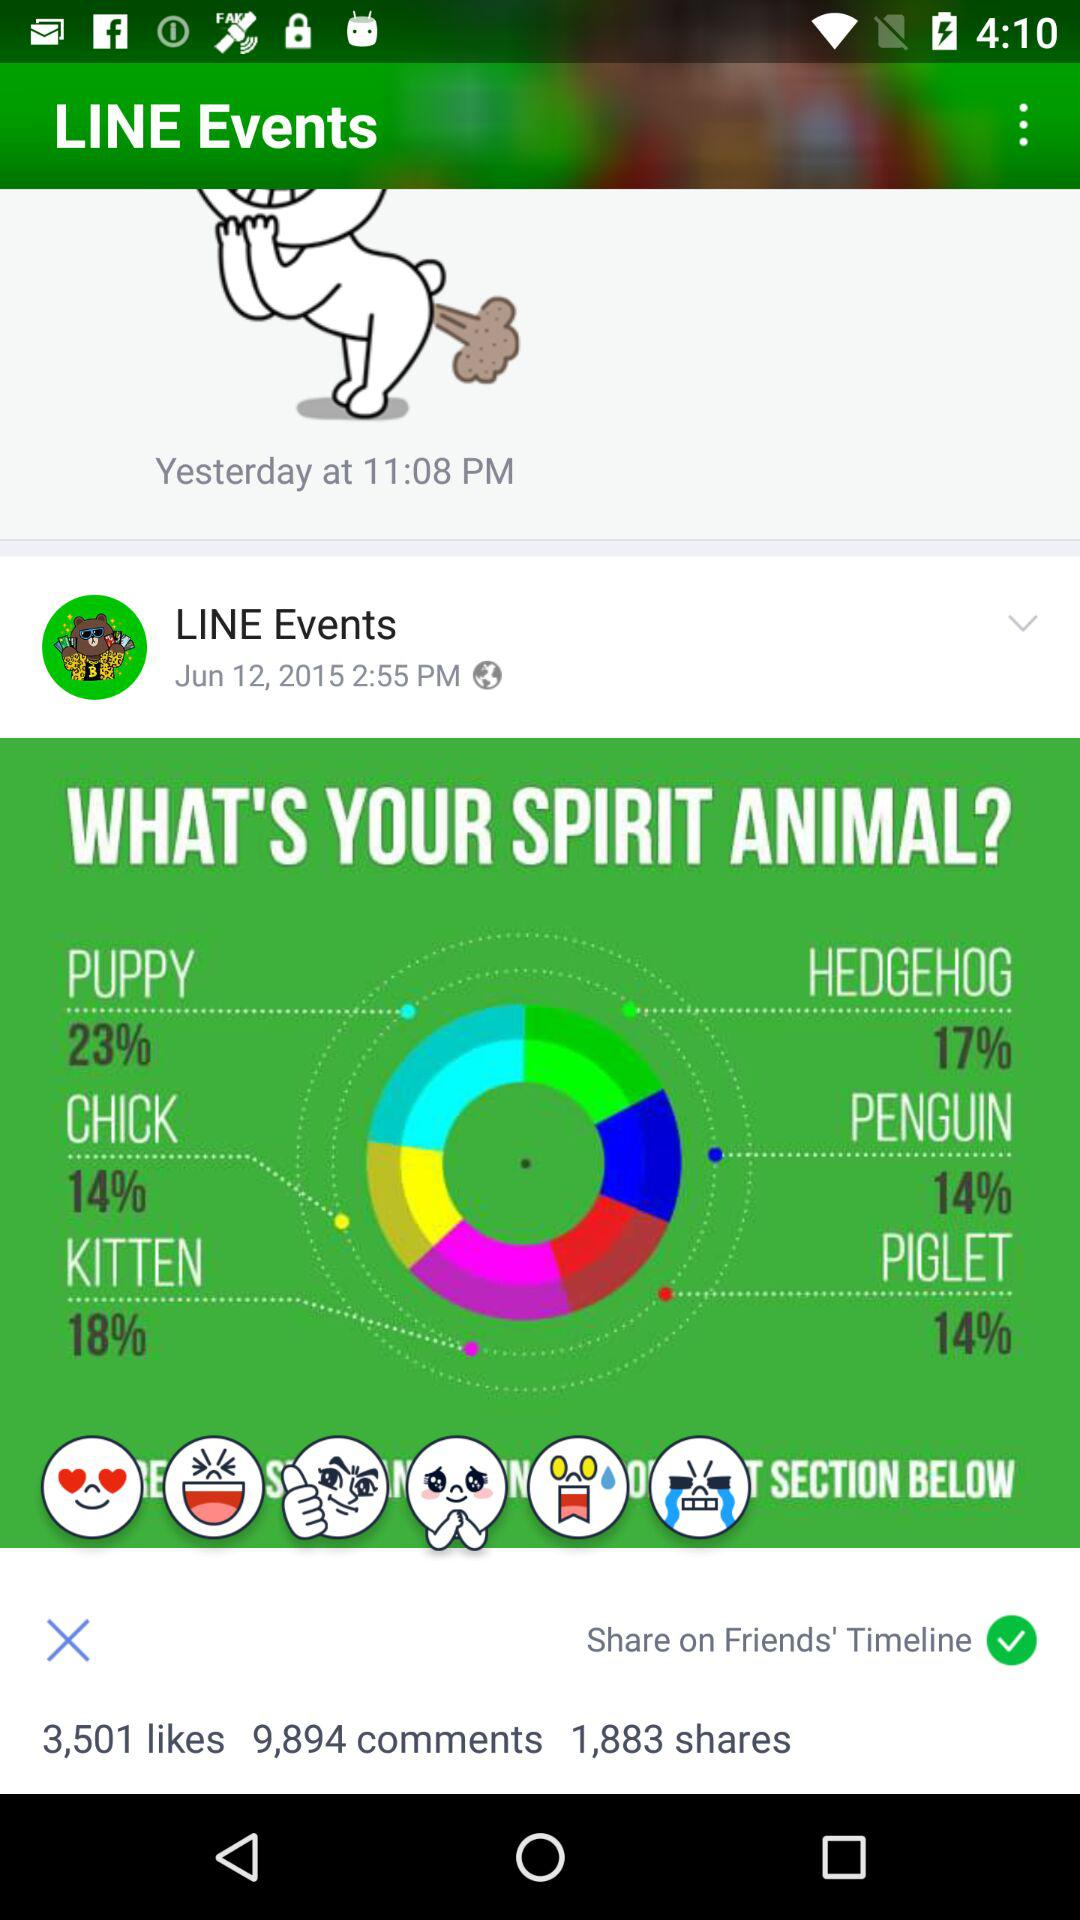How many shares are there? There are 1,883 shares. 